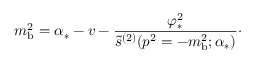<formula> <loc_0><loc_0><loc_500><loc_500>m _ { b } ^ { 2 } = \alpha _ { * } - v - { \frac { \varphi _ { * } ^ { 2 } } { \tilde { s } ^ { ( 2 ) } ( p ^ { 2 } = - m _ { b } ^ { 2 } ; \alpha _ { * } ) } } \cdot</formula> 